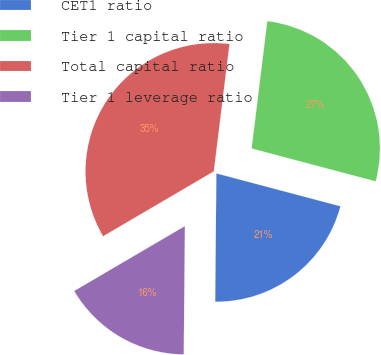Convert chart. <chart><loc_0><loc_0><loc_500><loc_500><pie_chart><fcel>CET1 ratio<fcel>Tier 1 capital ratio<fcel>Total capital ratio<fcel>Tier 1 leverage ratio<nl><fcel>21.02%<fcel>27.18%<fcel>35.39%<fcel>16.42%<nl></chart> 